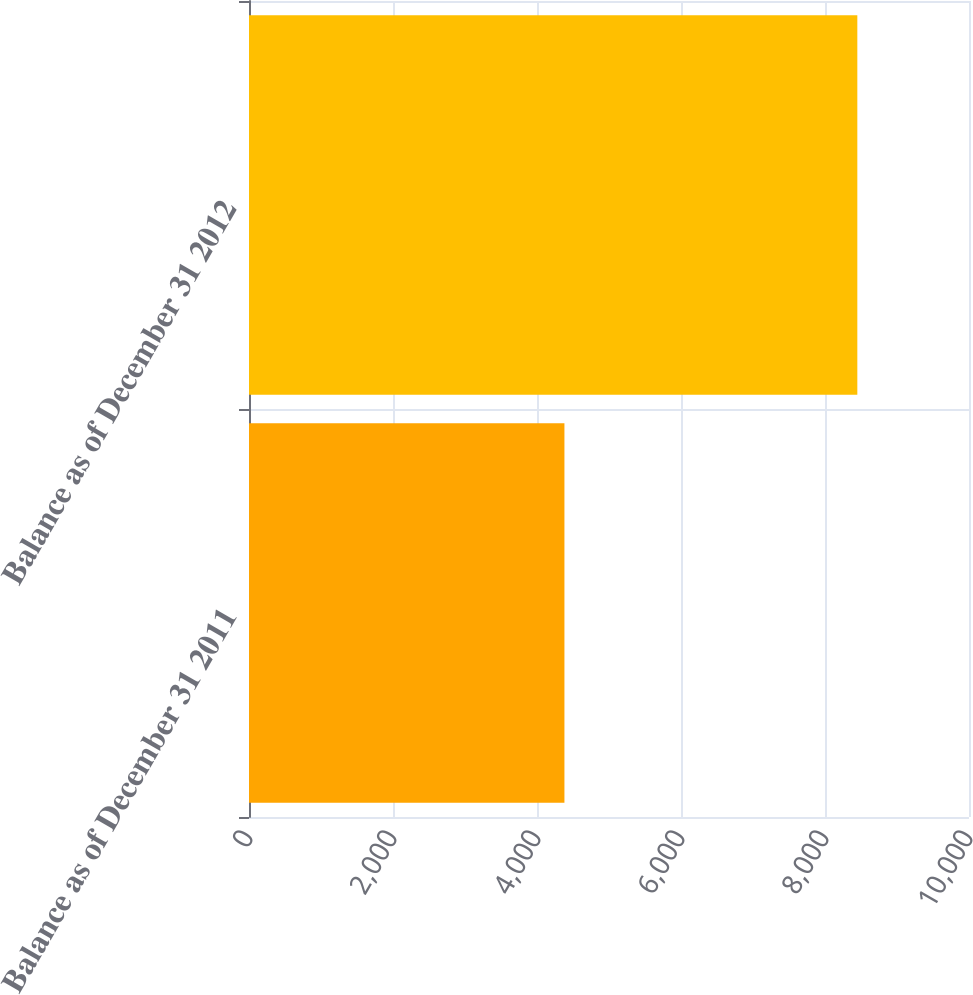Convert chart to OTSL. <chart><loc_0><loc_0><loc_500><loc_500><bar_chart><fcel>Balance as of December 31 2011<fcel>Balance as of December 31 2012<nl><fcel>4381<fcel>8449<nl></chart> 